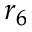<formula> <loc_0><loc_0><loc_500><loc_500>r _ { 6 }</formula> 